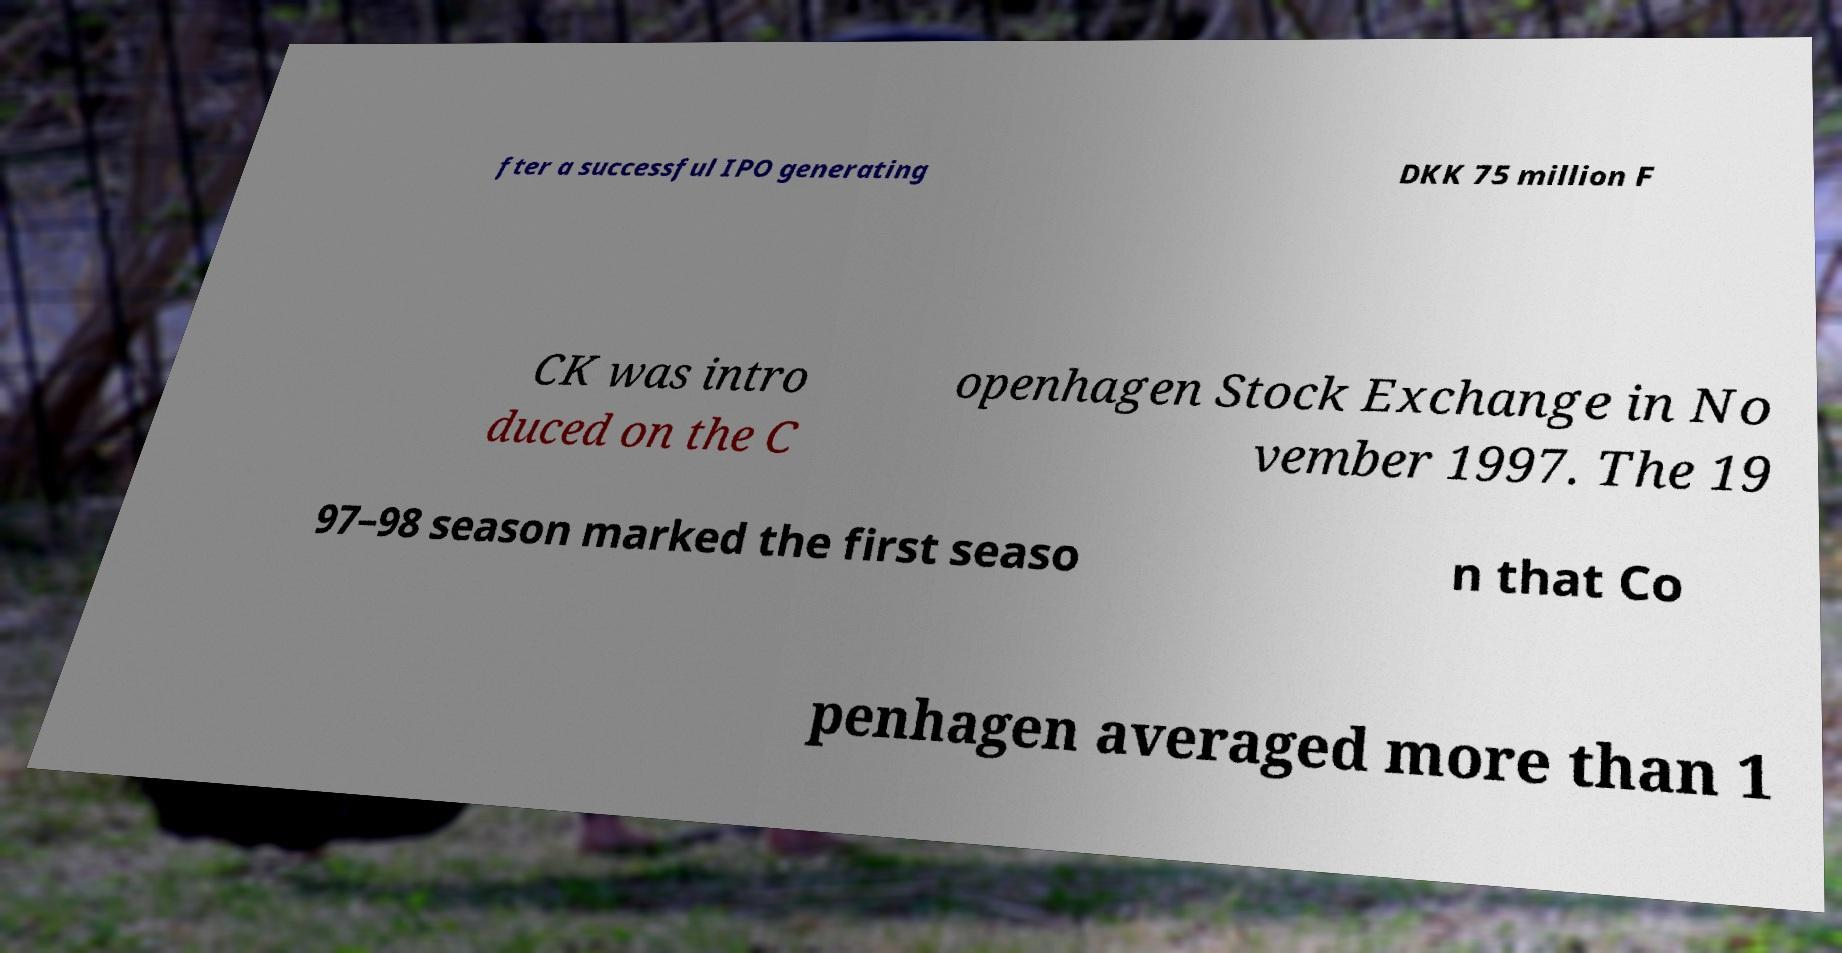For documentation purposes, I need the text within this image transcribed. Could you provide that? fter a successful IPO generating DKK 75 million F CK was intro duced on the C openhagen Stock Exchange in No vember 1997. The 19 97–98 season marked the first seaso n that Co penhagen averaged more than 1 